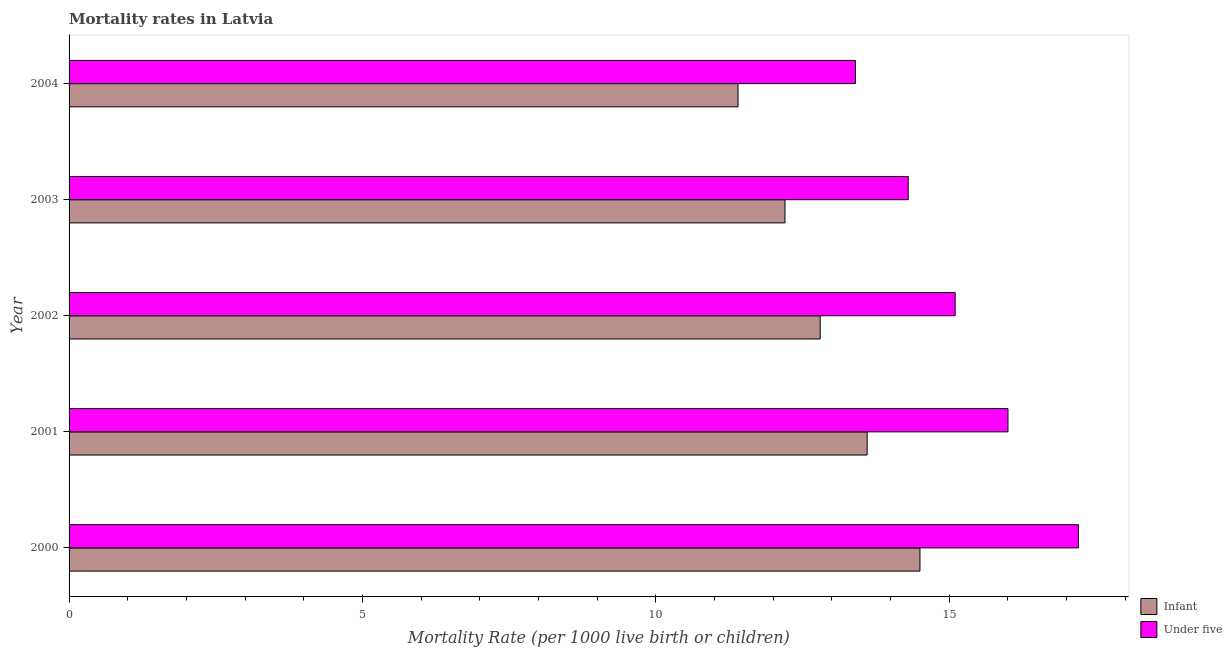Are the number of bars on each tick of the Y-axis equal?
Offer a very short reply. Yes. How many bars are there on the 5th tick from the top?
Provide a succinct answer. 2. How many bars are there on the 4th tick from the bottom?
Make the answer very short. 2. In how many cases, is the number of bars for a given year not equal to the number of legend labels?
Offer a terse response. 0. Across all years, what is the maximum infant mortality rate?
Provide a succinct answer. 14.5. Across all years, what is the minimum infant mortality rate?
Ensure brevity in your answer.  11.4. In which year was the under-5 mortality rate maximum?
Your answer should be very brief. 2000. In which year was the under-5 mortality rate minimum?
Your answer should be very brief. 2004. What is the total under-5 mortality rate in the graph?
Provide a succinct answer. 76. What is the difference between the under-5 mortality rate in 2004 and the infant mortality rate in 2003?
Give a very brief answer. 1.2. In how many years, is the infant mortality rate greater than 13 ?
Provide a succinct answer. 2. What is the ratio of the infant mortality rate in 2003 to that in 2004?
Ensure brevity in your answer.  1.07. In how many years, is the under-5 mortality rate greater than the average under-5 mortality rate taken over all years?
Your response must be concise. 2. What does the 2nd bar from the top in 2004 represents?
Your answer should be very brief. Infant. What does the 1st bar from the bottom in 2002 represents?
Your response must be concise. Infant. How many bars are there?
Your answer should be compact. 10. Are all the bars in the graph horizontal?
Ensure brevity in your answer.  Yes. How many years are there in the graph?
Offer a very short reply. 5. Where does the legend appear in the graph?
Make the answer very short. Bottom right. What is the title of the graph?
Your response must be concise. Mortality rates in Latvia. What is the label or title of the X-axis?
Ensure brevity in your answer.  Mortality Rate (per 1000 live birth or children). What is the label or title of the Y-axis?
Your response must be concise. Year. What is the Mortality Rate (per 1000 live birth or children) in Infant in 2001?
Make the answer very short. 13.6. What is the Mortality Rate (per 1000 live birth or children) of Infant in 2002?
Offer a very short reply. 12.8. What is the Mortality Rate (per 1000 live birth or children) in Under five in 2004?
Offer a very short reply. 13.4. Across all years, what is the maximum Mortality Rate (per 1000 live birth or children) in Infant?
Ensure brevity in your answer.  14.5. What is the total Mortality Rate (per 1000 live birth or children) of Infant in the graph?
Keep it short and to the point. 64.5. What is the total Mortality Rate (per 1000 live birth or children) in Under five in the graph?
Give a very brief answer. 76. What is the difference between the Mortality Rate (per 1000 live birth or children) in Infant in 2000 and that in 2001?
Make the answer very short. 0.9. What is the difference between the Mortality Rate (per 1000 live birth or children) of Under five in 2000 and that in 2002?
Your answer should be compact. 2.1. What is the difference between the Mortality Rate (per 1000 live birth or children) in Infant in 2001 and that in 2002?
Offer a terse response. 0.8. What is the difference between the Mortality Rate (per 1000 live birth or children) in Under five in 2001 and that in 2002?
Ensure brevity in your answer.  0.9. What is the difference between the Mortality Rate (per 1000 live birth or children) of Under five in 2001 and that in 2003?
Provide a succinct answer. 1.7. What is the difference between the Mortality Rate (per 1000 live birth or children) in Infant in 2002 and that in 2003?
Your answer should be very brief. 0.6. What is the difference between the Mortality Rate (per 1000 live birth or children) in Under five in 2002 and that in 2003?
Your answer should be very brief. 0.8. What is the difference between the Mortality Rate (per 1000 live birth or children) of Infant in 2002 and that in 2004?
Your answer should be compact. 1.4. What is the difference between the Mortality Rate (per 1000 live birth or children) in Infant in 2000 and the Mortality Rate (per 1000 live birth or children) in Under five in 2004?
Keep it short and to the point. 1.1. What is the difference between the Mortality Rate (per 1000 live birth or children) in Infant in 2001 and the Mortality Rate (per 1000 live birth or children) in Under five in 2004?
Provide a succinct answer. 0.2. What is the difference between the Mortality Rate (per 1000 live birth or children) in Infant in 2002 and the Mortality Rate (per 1000 live birth or children) in Under five in 2004?
Offer a terse response. -0.6. What is the difference between the Mortality Rate (per 1000 live birth or children) of Infant in 2003 and the Mortality Rate (per 1000 live birth or children) of Under five in 2004?
Your response must be concise. -1.2. What is the average Mortality Rate (per 1000 live birth or children) in Infant per year?
Keep it short and to the point. 12.9. In the year 2000, what is the difference between the Mortality Rate (per 1000 live birth or children) in Infant and Mortality Rate (per 1000 live birth or children) in Under five?
Provide a succinct answer. -2.7. In the year 2004, what is the difference between the Mortality Rate (per 1000 live birth or children) of Infant and Mortality Rate (per 1000 live birth or children) of Under five?
Your answer should be compact. -2. What is the ratio of the Mortality Rate (per 1000 live birth or children) in Infant in 2000 to that in 2001?
Give a very brief answer. 1.07. What is the ratio of the Mortality Rate (per 1000 live birth or children) of Under five in 2000 to that in 2001?
Keep it short and to the point. 1.07. What is the ratio of the Mortality Rate (per 1000 live birth or children) of Infant in 2000 to that in 2002?
Give a very brief answer. 1.13. What is the ratio of the Mortality Rate (per 1000 live birth or children) in Under five in 2000 to that in 2002?
Provide a short and direct response. 1.14. What is the ratio of the Mortality Rate (per 1000 live birth or children) in Infant in 2000 to that in 2003?
Offer a terse response. 1.19. What is the ratio of the Mortality Rate (per 1000 live birth or children) of Under five in 2000 to that in 2003?
Make the answer very short. 1.2. What is the ratio of the Mortality Rate (per 1000 live birth or children) of Infant in 2000 to that in 2004?
Your response must be concise. 1.27. What is the ratio of the Mortality Rate (per 1000 live birth or children) of Under five in 2000 to that in 2004?
Provide a short and direct response. 1.28. What is the ratio of the Mortality Rate (per 1000 live birth or children) in Under five in 2001 to that in 2002?
Keep it short and to the point. 1.06. What is the ratio of the Mortality Rate (per 1000 live birth or children) in Infant in 2001 to that in 2003?
Your answer should be very brief. 1.11. What is the ratio of the Mortality Rate (per 1000 live birth or children) in Under five in 2001 to that in 2003?
Your answer should be compact. 1.12. What is the ratio of the Mortality Rate (per 1000 live birth or children) of Infant in 2001 to that in 2004?
Ensure brevity in your answer.  1.19. What is the ratio of the Mortality Rate (per 1000 live birth or children) in Under five in 2001 to that in 2004?
Ensure brevity in your answer.  1.19. What is the ratio of the Mortality Rate (per 1000 live birth or children) of Infant in 2002 to that in 2003?
Offer a terse response. 1.05. What is the ratio of the Mortality Rate (per 1000 live birth or children) in Under five in 2002 to that in 2003?
Provide a short and direct response. 1.06. What is the ratio of the Mortality Rate (per 1000 live birth or children) in Infant in 2002 to that in 2004?
Keep it short and to the point. 1.12. What is the ratio of the Mortality Rate (per 1000 live birth or children) in Under five in 2002 to that in 2004?
Your answer should be very brief. 1.13. What is the ratio of the Mortality Rate (per 1000 live birth or children) in Infant in 2003 to that in 2004?
Give a very brief answer. 1.07. What is the ratio of the Mortality Rate (per 1000 live birth or children) of Under five in 2003 to that in 2004?
Your answer should be compact. 1.07. What is the difference between the highest and the second highest Mortality Rate (per 1000 live birth or children) of Infant?
Give a very brief answer. 0.9. What is the difference between the highest and the second highest Mortality Rate (per 1000 live birth or children) of Under five?
Your answer should be very brief. 1.2. What is the difference between the highest and the lowest Mortality Rate (per 1000 live birth or children) in Infant?
Your response must be concise. 3.1. What is the difference between the highest and the lowest Mortality Rate (per 1000 live birth or children) in Under five?
Your answer should be very brief. 3.8. 